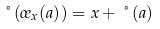Convert formula to latex. <formula><loc_0><loc_0><loc_500><loc_500>\nu ( \sigma _ { x } ( a ) ) = x + \nu ( a )</formula> 